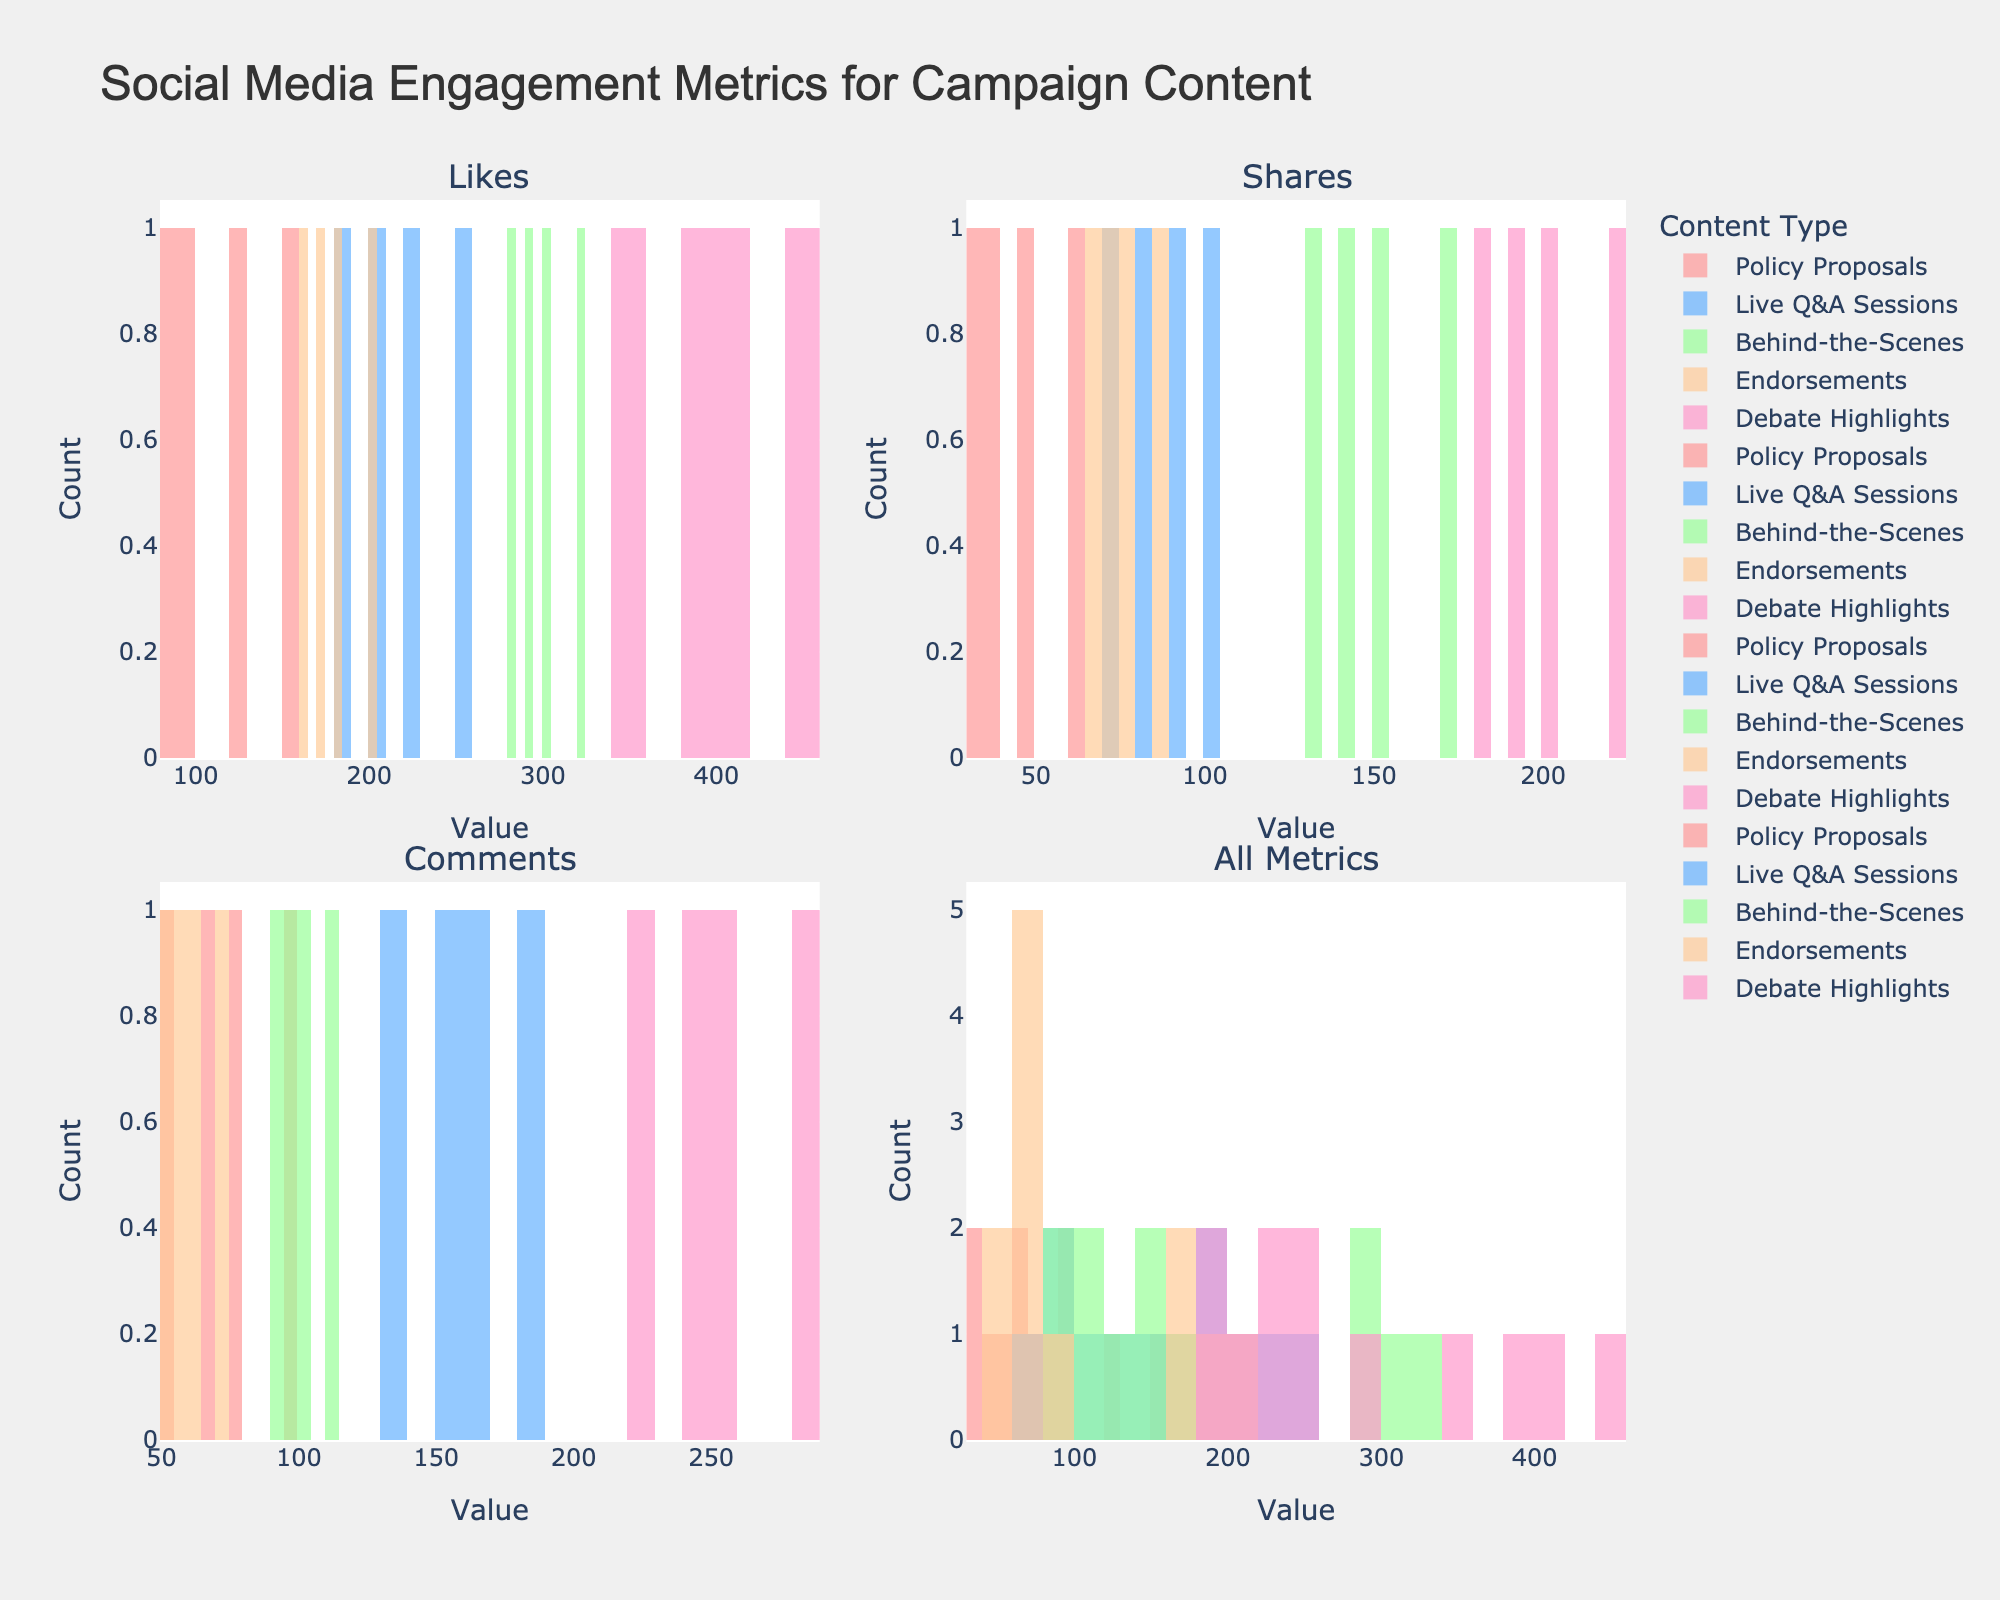How many histogram plots are shown in the figure? The figure contains multiple histograms grouped into four subplots titled 'Likes', 'Shares', 'Comments', and 'All Metrics'. Each subplot compares the engagement metrics across different content types.
Answer: 4 Which content type has the highest number of likes? By examining the 'Likes' subplot, 'Debate Highlights' consistently shows the highest peak, indicating the highest number of likes compared to other content types.
Answer: Debate Highlights In the 'Shares' subplot, which content type shows the widest range of data points? In the 'Shares' subplot, 'Debate Highlights' distribution spans a wider range horizontally compared to the other content types, indicating a wider range of shares.
Answer: Debate Highlights For the 'Comments' metric, what is the maximum value observed across all content types? By observing the 'Comments' subplot, the highest value reached appears in the 'Debate Highlights' content type, and the value is close to 300.
Answer: 300 Which content type exhibits the lowest frequency of likes in the 'All Metrics' subplot? In the 'All Metrics' subplot, the histogram for 'Endorsements' shows smaller peaks compared to other content types, indicating the lowest frequency of likes.
Answer: Endorsements What is the average number of shares for 'Live Q&A Sessions' content type in the 'Shares' subplot? By summing the shares values for 'Live Q&A Sessions' (80, 70, 100, 90), we get a total of 340. Dividing by 4 gives an average share value of 85.
Answer: 85 Which content type seems to have the most balanced distribution across likes, shares, and comments? In the 'All Metrics' subplot, 'Behind-the-Scenes' content type shows relatively uniform distribution across all metrics, indicating a balanced distribution among likes, shares, and comments.
Answer: Behind-the-Scenes Comparing 'Policy Proposals' to 'Endorsements', which has higher engagement in terms of comments? In the 'Comments' subplot, the data for 'Policy Proposals' show higher peaks compared to 'Endorsements,' indicating higher engagement in terms of comments.
Answer: Policy Proposals How many bins are used to create the histogram in the 'All Metrics' subplot? By examining the x-axis intervals in the 'All Metrics' subplot, it appears that the data are divided into 15 bins.
Answer: 15 